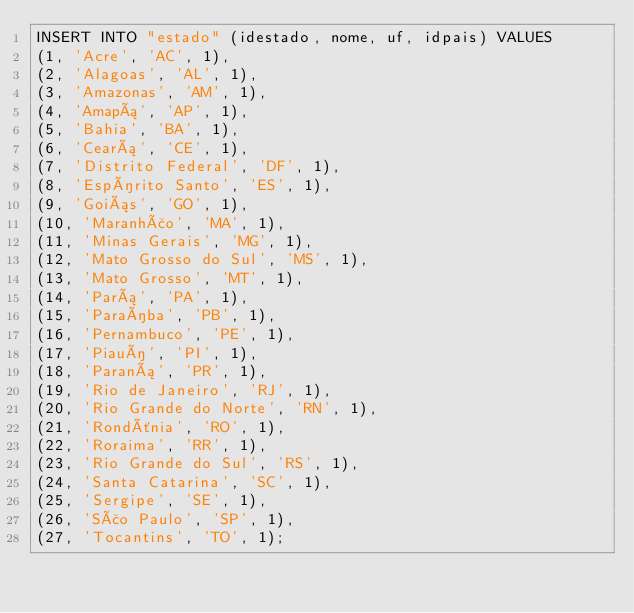Convert code to text. <code><loc_0><loc_0><loc_500><loc_500><_SQL_>INSERT INTO "estado" (idestado, nome, uf, idpais) VALUES
(1, 'Acre', 'AC', 1),
(2, 'Alagoas', 'AL', 1),
(3, 'Amazonas', 'AM', 1),
(4, 'Amapá', 'AP', 1),
(5, 'Bahia', 'BA', 1),
(6, 'Ceará', 'CE', 1),
(7, 'Distrito Federal', 'DF', 1),
(8, 'Espírito Santo', 'ES', 1),
(9, 'Goiás', 'GO', 1),
(10, 'Maranhão', 'MA', 1),
(11, 'Minas Gerais', 'MG', 1),
(12, 'Mato Grosso do Sul', 'MS', 1),
(13, 'Mato Grosso', 'MT', 1),
(14, 'Pará', 'PA', 1),
(15, 'Paraíba', 'PB', 1),
(16, 'Pernambuco', 'PE', 1),
(17, 'Piauí', 'PI', 1),
(18, 'Paraná', 'PR', 1),
(19, 'Rio de Janeiro', 'RJ', 1),
(20, 'Rio Grande do Norte', 'RN', 1),
(21, 'Rondônia', 'RO', 1),
(22, 'Roraima', 'RR', 1),
(23, 'Rio Grande do Sul', 'RS', 1),
(24, 'Santa Catarina', 'SC', 1),
(25, 'Sergipe', 'SE', 1),
(26, 'São Paulo', 'SP', 1),
(27, 'Tocantins', 'TO', 1);
</code> 